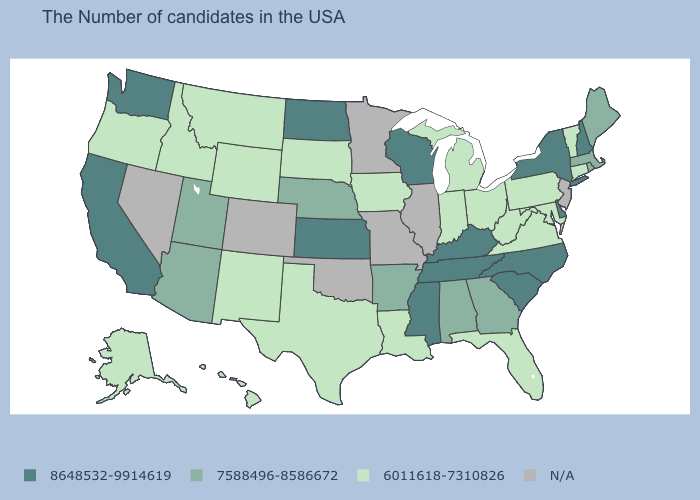What is the value of Kentucky?
Give a very brief answer. 8648532-9914619. Which states have the highest value in the USA?
Short answer required. New Hampshire, New York, Delaware, North Carolina, South Carolina, Kentucky, Tennessee, Wisconsin, Mississippi, Kansas, North Dakota, California, Washington. What is the value of Alabama?
Keep it brief. 7588496-8586672. Name the states that have a value in the range 8648532-9914619?
Concise answer only. New Hampshire, New York, Delaware, North Carolina, South Carolina, Kentucky, Tennessee, Wisconsin, Mississippi, Kansas, North Dakota, California, Washington. What is the value of Iowa?
Short answer required. 6011618-7310826. Among the states that border Massachusetts , which have the lowest value?
Write a very short answer. Vermont, Connecticut. Among the states that border Texas , does New Mexico have the highest value?
Concise answer only. No. What is the highest value in the USA?
Keep it brief. 8648532-9914619. What is the value of Minnesota?
Concise answer only. N/A. What is the value of West Virginia?
Short answer required. 6011618-7310826. Name the states that have a value in the range 8648532-9914619?
Short answer required. New Hampshire, New York, Delaware, North Carolina, South Carolina, Kentucky, Tennessee, Wisconsin, Mississippi, Kansas, North Dakota, California, Washington. Name the states that have a value in the range 7588496-8586672?
Be succinct. Maine, Massachusetts, Rhode Island, Georgia, Alabama, Arkansas, Nebraska, Utah, Arizona. Name the states that have a value in the range 7588496-8586672?
Concise answer only. Maine, Massachusetts, Rhode Island, Georgia, Alabama, Arkansas, Nebraska, Utah, Arizona. Among the states that border Wisconsin , which have the lowest value?
Give a very brief answer. Michigan, Iowa. 